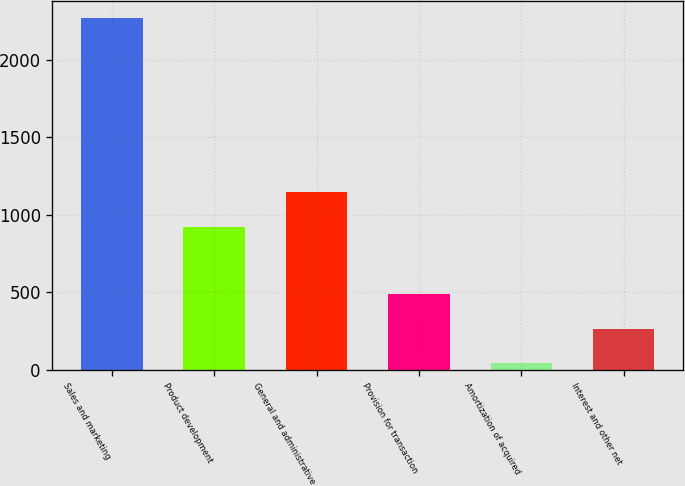Convert chart. <chart><loc_0><loc_0><loc_500><loc_500><bar_chart><fcel>Sales and marketing<fcel>Product development<fcel>General and administrative<fcel>Provision for transaction<fcel>Amortization of acquired<fcel>Interest and other net<nl><fcel>2267<fcel>923<fcel>1145.6<fcel>486.2<fcel>41<fcel>263.6<nl></chart> 